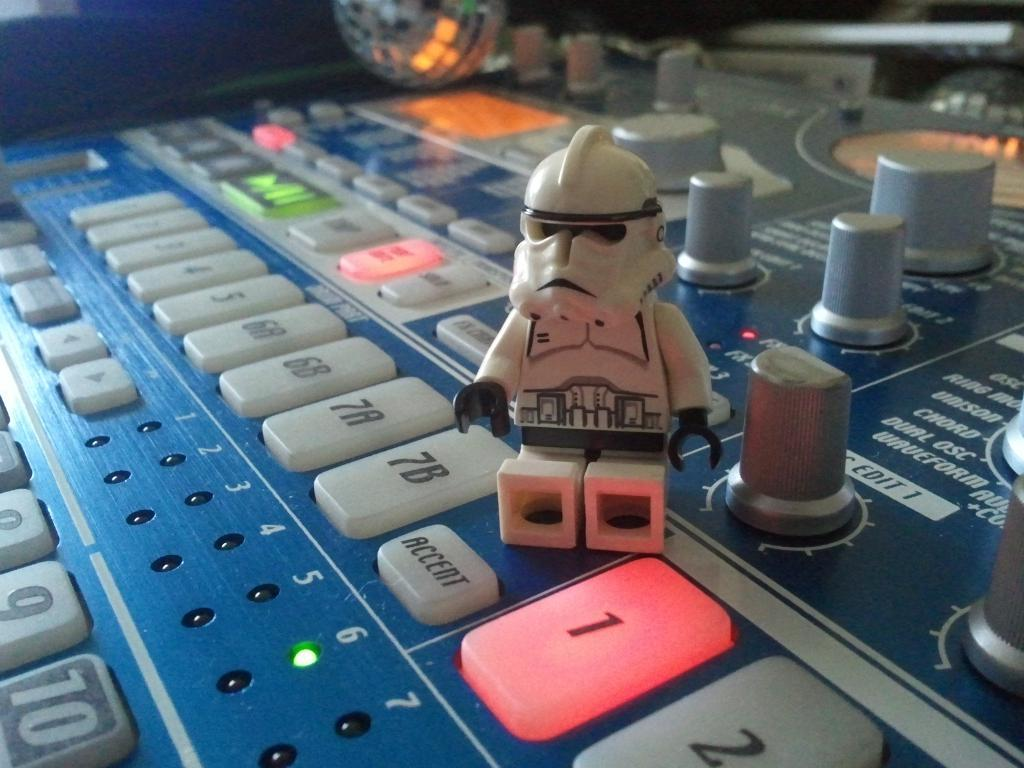Provide a one-sentence caption for the provided image. A lego storm trooper beside a "1" button that is lit up red on a console. 